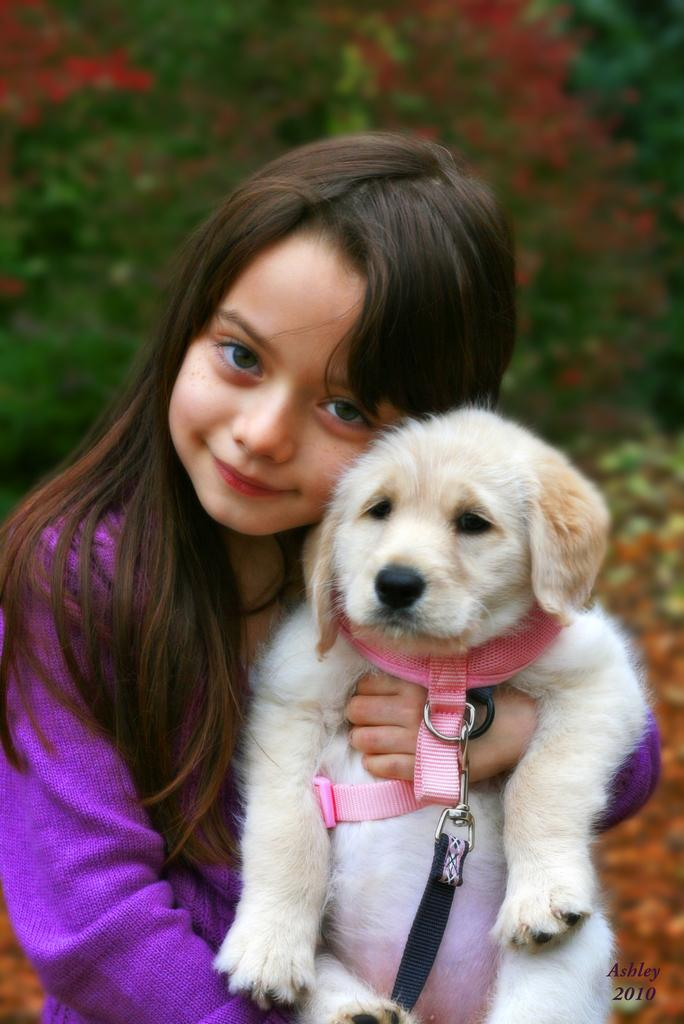What is the main subject of the image? There is a child in the image. What is the child wearing? The child is wearing a purple dress. What is the child holding in the image? The child is holding a dog. What can be seen in the background of the image? There are trees in the background of the image. How many pies are being baked by the child in the image? There are no pies present in the image; the child is holding a dog. What type of glue is being used by the child to stick the dog to the dress? There is no glue present in the image, and the child is not attempting to stick the dog to their dress. 